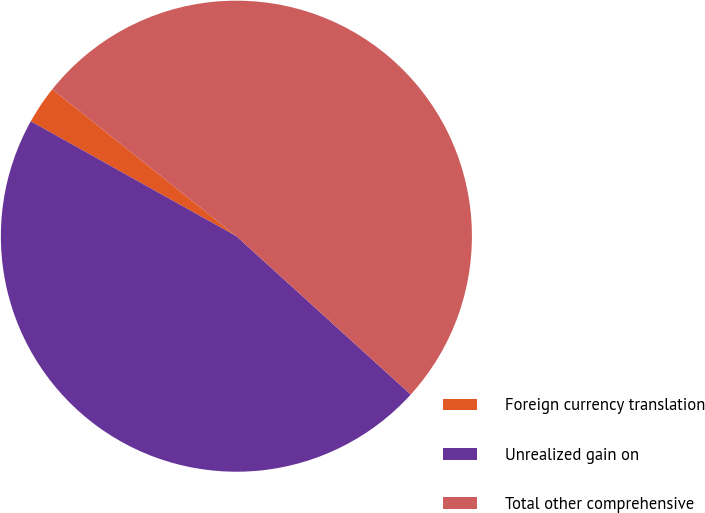<chart> <loc_0><loc_0><loc_500><loc_500><pie_chart><fcel>Foreign currency translation<fcel>Unrealized gain on<fcel>Total other comprehensive<nl><fcel>2.61%<fcel>46.38%<fcel>51.02%<nl></chart> 